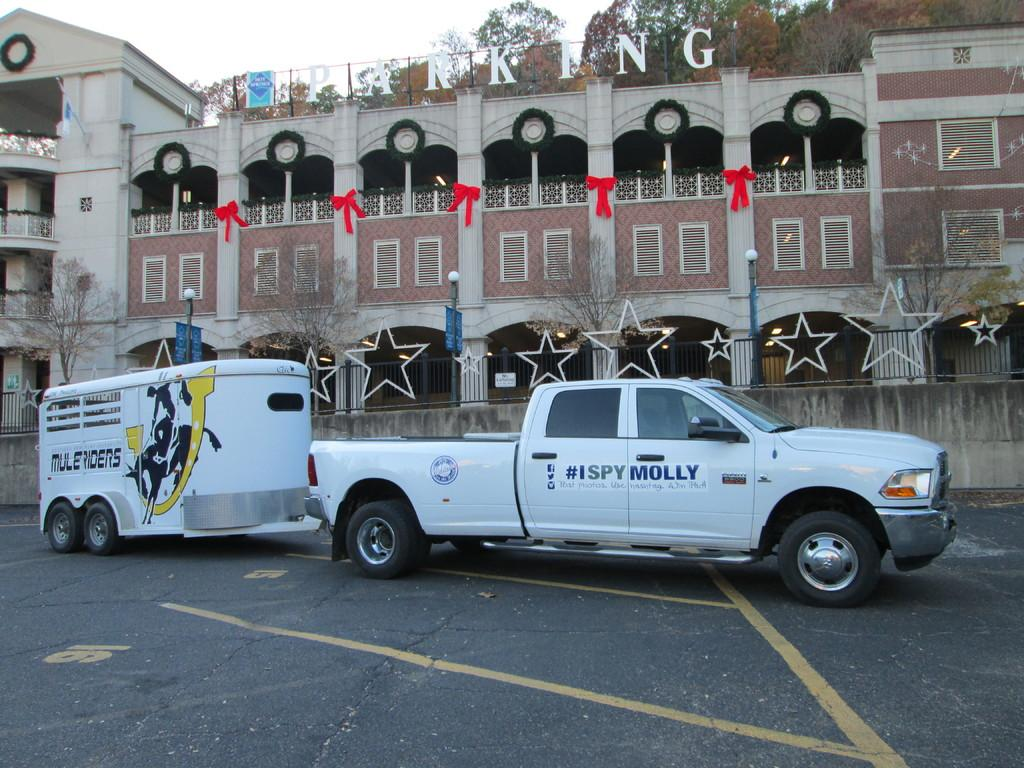What type of structure is present in the image? There is a building in the image. Can you describe any text or signage on the building? Yes, there is text written on the building. What else can be seen in the image besides the building? There are vehicles and trees visible in the image. What is visible in the background of the image? The sky is visible in the image. What type of whip can be seen hanging from the building in the image? There is no whip present in the image; it features a building with text, vehicles, trees, and a visible sky. How does the bulb on the building roll in the image? There is no bulb present in the image, and therefore no such activity can be observed. 